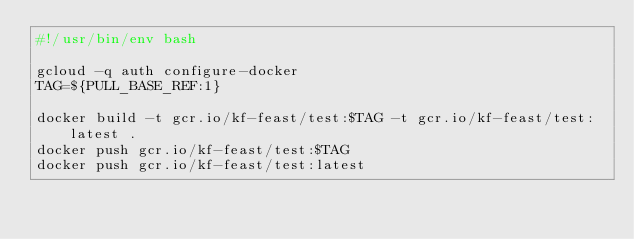Convert code to text. <code><loc_0><loc_0><loc_500><loc_500><_Bash_>#!/usr/bin/env bash

gcloud -q auth configure-docker
TAG=${PULL_BASE_REF:1}

docker build -t gcr.io/kf-feast/test:$TAG -t gcr.io/kf-feast/test:latest .
docker push gcr.io/kf-feast/test:$TAG
docker push gcr.io/kf-feast/test:latest
</code> 